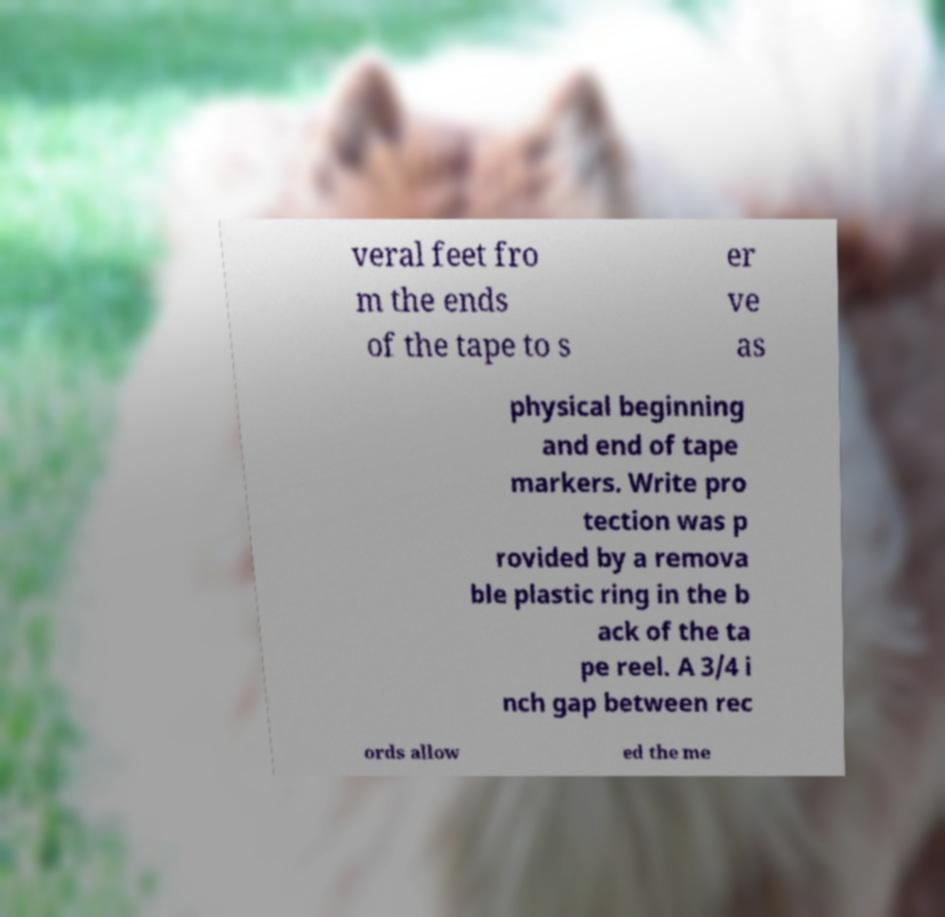Please identify and transcribe the text found in this image. veral feet fro m the ends of the tape to s er ve as physical beginning and end of tape markers. Write pro tection was p rovided by a remova ble plastic ring in the b ack of the ta pe reel. A 3/4 i nch gap between rec ords allow ed the me 